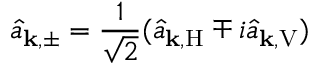Convert formula to latex. <formula><loc_0><loc_0><loc_500><loc_500>\hat { a } _ { k , \pm } = \frac { 1 } { \sqrt { 2 } } ( \hat { a } _ { k , H } \mp i \hat { a } _ { k , V } )</formula> 